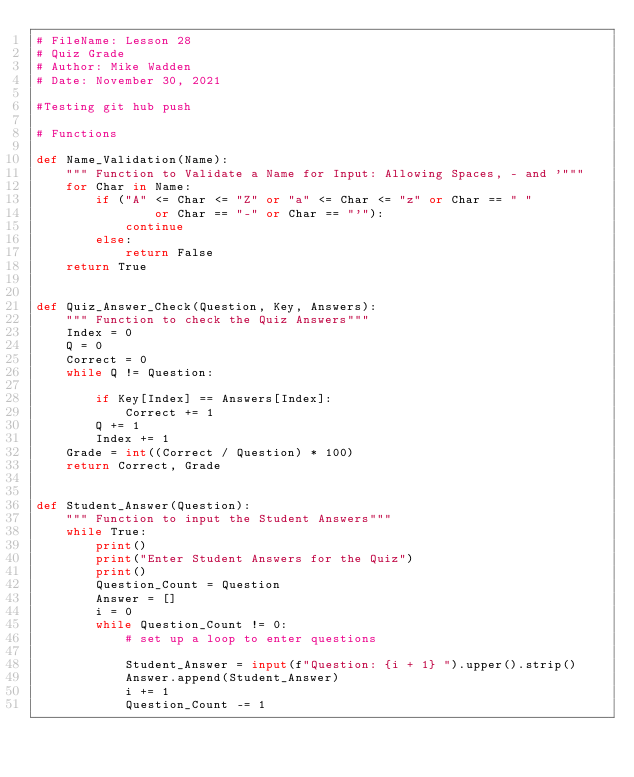Convert code to text. <code><loc_0><loc_0><loc_500><loc_500><_Python_># FileName: Lesson 28
# Quiz Grade
# Author: Mike Wadden
# Date: November 30, 2021

#Testing git hub push

# Functions

def Name_Validation(Name):
    """ Function to Validate a Name for Input: Allowing Spaces, - and '"""
    for Char in Name:
        if ("A" <= Char <= "Z" or "a" <= Char <= "z" or Char == " "
                or Char == "-" or Char == "'"):
            continue
        else:
            return False
    return True


def Quiz_Answer_Check(Question, Key, Answers):
    """ Function to check the Quiz Answers"""
    Index = 0
    Q = 0
    Correct = 0
    while Q != Question:

        if Key[Index] == Answers[Index]:
            Correct += 1
        Q += 1
        Index += 1
    Grade = int((Correct / Question) * 100)
    return Correct, Grade


def Student_Answer(Question):
    """ Function to input the Student Answers"""
    while True:
        print()
        print("Enter Student Answers for the Quiz")
        print()
        Question_Count = Question
        Answer = []
        i = 0
        while Question_Count != 0:
            # set up a loop to enter questions

            Student_Answer = input(f"Question: {i + 1} ").upper().strip()
            Answer.append(Student_Answer)
            i += 1
            Question_Count -= 1
</code> 